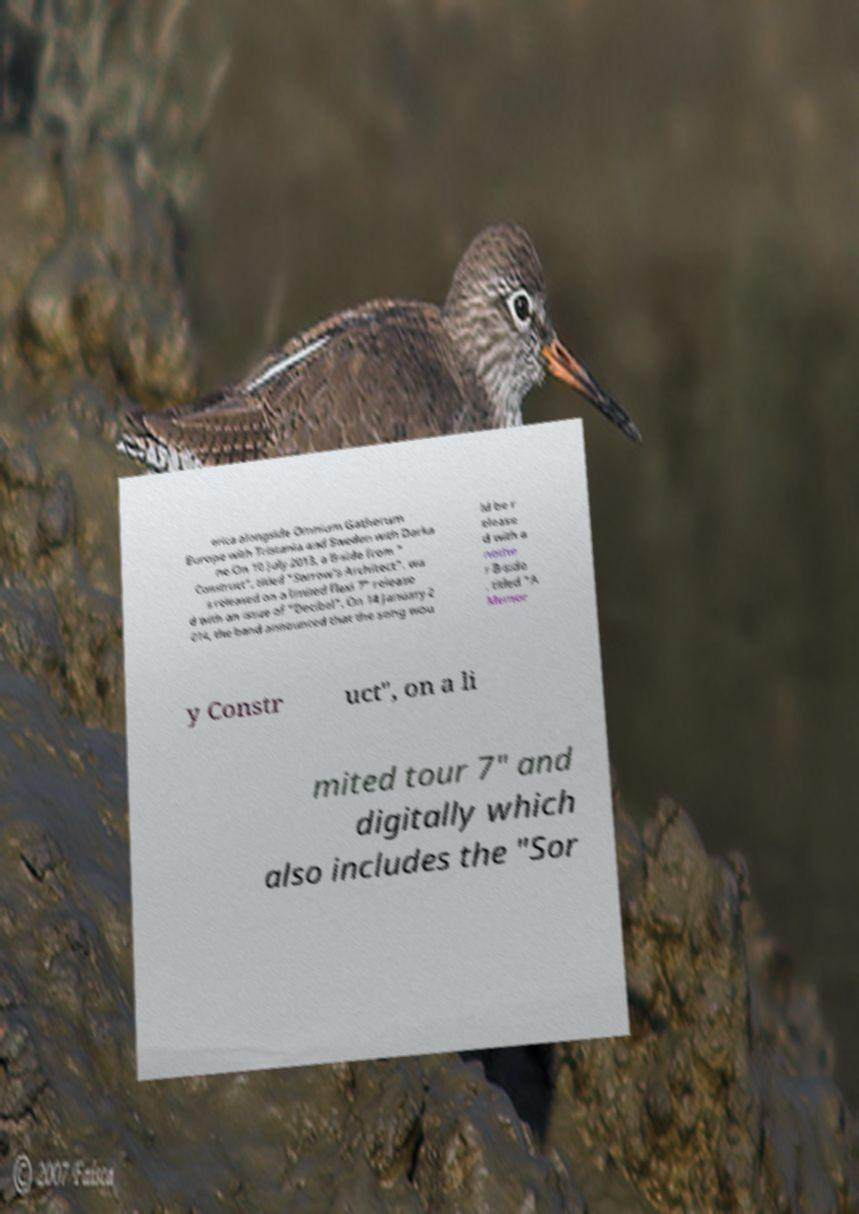There's text embedded in this image that I need extracted. Can you transcribe it verbatim? erica alongside Omnium Gatherum Europe with Tristania and Sweden with Darka ne.On 10 July 2013, a B-side from " Construct", titled "Sorrow's Architect", wa s released on a limited flexi 7" release d with an issue of "Decibel". On 14 January 2 014, the band announced that the song wou ld be r elease d with a nothe r B-side , titled "A Memor y Constr uct", on a li mited tour 7" and digitally which also includes the "Sor 